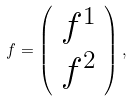<formula> <loc_0><loc_0><loc_500><loc_500>f = \left ( \begin{array} { c } f ^ { 1 } \\ f ^ { 2 } \end{array} \right ) ,</formula> 